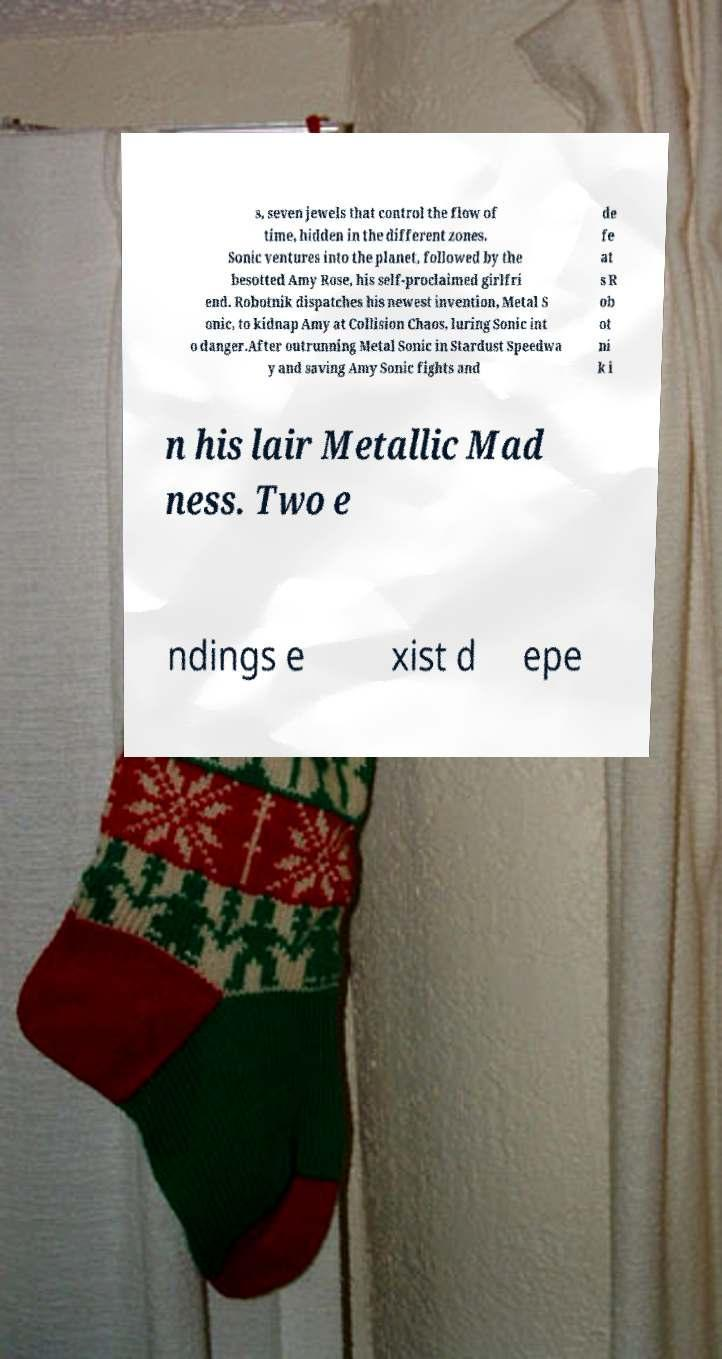Please identify and transcribe the text found in this image. s, seven jewels that control the flow of time, hidden in the different zones. Sonic ventures into the planet, followed by the besotted Amy Rose, his self-proclaimed girlfri end. Robotnik dispatches his newest invention, Metal S onic, to kidnap Amy at Collision Chaos, luring Sonic int o danger.After outrunning Metal Sonic in Stardust Speedwa y and saving Amy Sonic fights and de fe at s R ob ot ni k i n his lair Metallic Mad ness. Two e ndings e xist d epe 